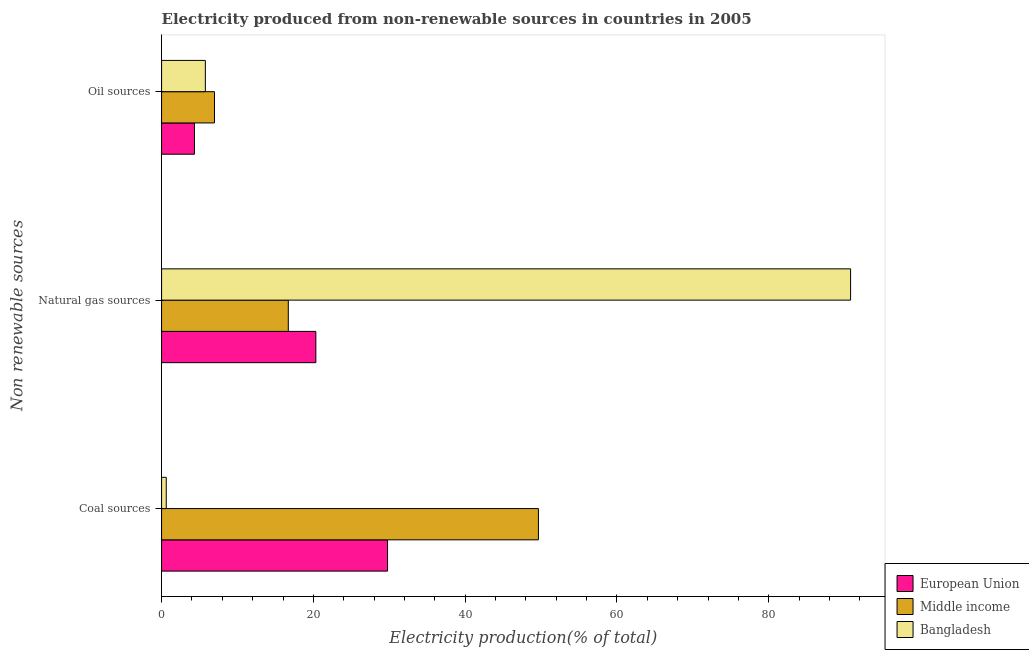Are the number of bars per tick equal to the number of legend labels?
Provide a short and direct response. Yes. Are the number of bars on each tick of the Y-axis equal?
Your answer should be very brief. Yes. What is the label of the 1st group of bars from the top?
Your response must be concise. Oil sources. What is the percentage of electricity produced by natural gas in Middle income?
Your response must be concise. 16.7. Across all countries, what is the maximum percentage of electricity produced by natural gas?
Ensure brevity in your answer.  90.78. Across all countries, what is the minimum percentage of electricity produced by natural gas?
Your answer should be very brief. 16.7. What is the total percentage of electricity produced by coal in the graph?
Provide a short and direct response. 80.04. What is the difference between the percentage of electricity produced by coal in Middle income and that in European Union?
Offer a terse response. 19.88. What is the difference between the percentage of electricity produced by oil sources in Middle income and the percentage of electricity produced by coal in European Union?
Offer a very short reply. -22.8. What is the average percentage of electricity produced by oil sources per country?
Make the answer very short. 5.69. What is the difference between the percentage of electricity produced by natural gas and percentage of electricity produced by coal in Middle income?
Keep it short and to the point. -32.96. What is the ratio of the percentage of electricity produced by natural gas in Middle income to that in Bangladesh?
Your answer should be very brief. 0.18. Is the percentage of electricity produced by oil sources in European Union less than that in Middle income?
Make the answer very short. Yes. Is the difference between the percentage of electricity produced by oil sources in European Union and Bangladesh greater than the difference between the percentage of electricity produced by natural gas in European Union and Bangladesh?
Your answer should be compact. Yes. What is the difference between the highest and the second highest percentage of electricity produced by coal?
Ensure brevity in your answer.  19.88. What is the difference between the highest and the lowest percentage of electricity produced by coal?
Provide a succinct answer. 49.03. In how many countries, is the percentage of electricity produced by coal greater than the average percentage of electricity produced by coal taken over all countries?
Provide a short and direct response. 2. What does the 3rd bar from the top in Natural gas sources represents?
Your response must be concise. European Union. What does the 1st bar from the bottom in Natural gas sources represents?
Provide a short and direct response. European Union. What is the difference between two consecutive major ticks on the X-axis?
Your answer should be compact. 20. Does the graph contain any zero values?
Ensure brevity in your answer.  No. Does the graph contain grids?
Ensure brevity in your answer.  No. Where does the legend appear in the graph?
Keep it short and to the point. Bottom right. How many legend labels are there?
Provide a succinct answer. 3. What is the title of the graph?
Offer a terse response. Electricity produced from non-renewable sources in countries in 2005. What is the label or title of the Y-axis?
Offer a very short reply. Non renewable sources. What is the Electricity production(% of total) in European Union in Coal sources?
Provide a succinct answer. 29.77. What is the Electricity production(% of total) of Middle income in Coal sources?
Offer a very short reply. 49.65. What is the Electricity production(% of total) of Bangladesh in Coal sources?
Your answer should be compact. 0.62. What is the Electricity production(% of total) of European Union in Natural gas sources?
Your answer should be compact. 20.33. What is the Electricity production(% of total) of Middle income in Natural gas sources?
Your response must be concise. 16.7. What is the Electricity production(% of total) of Bangladesh in Natural gas sources?
Your response must be concise. 90.78. What is the Electricity production(% of total) in European Union in Oil sources?
Your response must be concise. 4.33. What is the Electricity production(% of total) of Middle income in Oil sources?
Offer a terse response. 6.97. What is the Electricity production(% of total) in Bangladesh in Oil sources?
Your answer should be very brief. 5.77. Across all Non renewable sources, what is the maximum Electricity production(% of total) in European Union?
Give a very brief answer. 29.77. Across all Non renewable sources, what is the maximum Electricity production(% of total) in Middle income?
Your response must be concise. 49.65. Across all Non renewable sources, what is the maximum Electricity production(% of total) in Bangladesh?
Give a very brief answer. 90.78. Across all Non renewable sources, what is the minimum Electricity production(% of total) in European Union?
Provide a short and direct response. 4.33. Across all Non renewable sources, what is the minimum Electricity production(% of total) of Middle income?
Ensure brevity in your answer.  6.97. Across all Non renewable sources, what is the minimum Electricity production(% of total) in Bangladesh?
Offer a terse response. 0.62. What is the total Electricity production(% of total) in European Union in the graph?
Ensure brevity in your answer.  54.43. What is the total Electricity production(% of total) of Middle income in the graph?
Provide a succinct answer. 73.32. What is the total Electricity production(% of total) of Bangladesh in the graph?
Provide a succinct answer. 97.17. What is the difference between the Electricity production(% of total) in European Union in Coal sources and that in Natural gas sources?
Give a very brief answer. 9.45. What is the difference between the Electricity production(% of total) of Middle income in Coal sources and that in Natural gas sources?
Offer a terse response. 32.95. What is the difference between the Electricity production(% of total) in Bangladesh in Coal sources and that in Natural gas sources?
Keep it short and to the point. -90.17. What is the difference between the Electricity production(% of total) in European Union in Coal sources and that in Oil sources?
Keep it short and to the point. 25.44. What is the difference between the Electricity production(% of total) of Middle income in Coal sources and that in Oil sources?
Make the answer very short. 42.68. What is the difference between the Electricity production(% of total) of Bangladesh in Coal sources and that in Oil sources?
Keep it short and to the point. -5.15. What is the difference between the Electricity production(% of total) of European Union in Natural gas sources and that in Oil sources?
Ensure brevity in your answer.  15.99. What is the difference between the Electricity production(% of total) in Middle income in Natural gas sources and that in Oil sources?
Ensure brevity in your answer.  9.72. What is the difference between the Electricity production(% of total) of Bangladesh in Natural gas sources and that in Oil sources?
Your answer should be very brief. 85.01. What is the difference between the Electricity production(% of total) of European Union in Coal sources and the Electricity production(% of total) of Middle income in Natural gas sources?
Provide a short and direct response. 13.08. What is the difference between the Electricity production(% of total) of European Union in Coal sources and the Electricity production(% of total) of Bangladesh in Natural gas sources?
Ensure brevity in your answer.  -61.01. What is the difference between the Electricity production(% of total) of Middle income in Coal sources and the Electricity production(% of total) of Bangladesh in Natural gas sources?
Make the answer very short. -41.13. What is the difference between the Electricity production(% of total) of European Union in Coal sources and the Electricity production(% of total) of Middle income in Oil sources?
Provide a succinct answer. 22.8. What is the difference between the Electricity production(% of total) of European Union in Coal sources and the Electricity production(% of total) of Bangladesh in Oil sources?
Your answer should be compact. 24. What is the difference between the Electricity production(% of total) in Middle income in Coal sources and the Electricity production(% of total) in Bangladesh in Oil sources?
Your answer should be very brief. 43.88. What is the difference between the Electricity production(% of total) of European Union in Natural gas sources and the Electricity production(% of total) of Middle income in Oil sources?
Provide a short and direct response. 13.35. What is the difference between the Electricity production(% of total) in European Union in Natural gas sources and the Electricity production(% of total) in Bangladesh in Oil sources?
Make the answer very short. 14.56. What is the difference between the Electricity production(% of total) in Middle income in Natural gas sources and the Electricity production(% of total) in Bangladesh in Oil sources?
Offer a very short reply. 10.93. What is the average Electricity production(% of total) in European Union per Non renewable sources?
Offer a very short reply. 18.14. What is the average Electricity production(% of total) of Middle income per Non renewable sources?
Your answer should be very brief. 24.44. What is the average Electricity production(% of total) in Bangladesh per Non renewable sources?
Your answer should be very brief. 32.39. What is the difference between the Electricity production(% of total) of European Union and Electricity production(% of total) of Middle income in Coal sources?
Make the answer very short. -19.88. What is the difference between the Electricity production(% of total) in European Union and Electricity production(% of total) in Bangladesh in Coal sources?
Your answer should be very brief. 29.16. What is the difference between the Electricity production(% of total) of Middle income and Electricity production(% of total) of Bangladesh in Coal sources?
Your answer should be very brief. 49.03. What is the difference between the Electricity production(% of total) of European Union and Electricity production(% of total) of Middle income in Natural gas sources?
Your answer should be very brief. 3.63. What is the difference between the Electricity production(% of total) in European Union and Electricity production(% of total) in Bangladesh in Natural gas sources?
Keep it short and to the point. -70.46. What is the difference between the Electricity production(% of total) in Middle income and Electricity production(% of total) in Bangladesh in Natural gas sources?
Your answer should be very brief. -74.09. What is the difference between the Electricity production(% of total) of European Union and Electricity production(% of total) of Middle income in Oil sources?
Make the answer very short. -2.64. What is the difference between the Electricity production(% of total) in European Union and Electricity production(% of total) in Bangladesh in Oil sources?
Your answer should be compact. -1.44. What is the difference between the Electricity production(% of total) of Middle income and Electricity production(% of total) of Bangladesh in Oil sources?
Your answer should be compact. 1.2. What is the ratio of the Electricity production(% of total) of European Union in Coal sources to that in Natural gas sources?
Ensure brevity in your answer.  1.46. What is the ratio of the Electricity production(% of total) in Middle income in Coal sources to that in Natural gas sources?
Your answer should be compact. 2.97. What is the ratio of the Electricity production(% of total) of Bangladesh in Coal sources to that in Natural gas sources?
Your answer should be very brief. 0.01. What is the ratio of the Electricity production(% of total) in European Union in Coal sources to that in Oil sources?
Your answer should be compact. 6.87. What is the ratio of the Electricity production(% of total) of Middle income in Coal sources to that in Oil sources?
Provide a short and direct response. 7.12. What is the ratio of the Electricity production(% of total) in Bangladesh in Coal sources to that in Oil sources?
Your answer should be compact. 0.11. What is the ratio of the Electricity production(% of total) in European Union in Natural gas sources to that in Oil sources?
Offer a terse response. 4.69. What is the ratio of the Electricity production(% of total) of Middle income in Natural gas sources to that in Oil sources?
Provide a succinct answer. 2.4. What is the ratio of the Electricity production(% of total) in Bangladesh in Natural gas sources to that in Oil sources?
Offer a very short reply. 15.73. What is the difference between the highest and the second highest Electricity production(% of total) of European Union?
Your answer should be compact. 9.45. What is the difference between the highest and the second highest Electricity production(% of total) in Middle income?
Your response must be concise. 32.95. What is the difference between the highest and the second highest Electricity production(% of total) of Bangladesh?
Keep it short and to the point. 85.01. What is the difference between the highest and the lowest Electricity production(% of total) in European Union?
Keep it short and to the point. 25.44. What is the difference between the highest and the lowest Electricity production(% of total) of Middle income?
Your answer should be very brief. 42.68. What is the difference between the highest and the lowest Electricity production(% of total) of Bangladesh?
Provide a short and direct response. 90.17. 